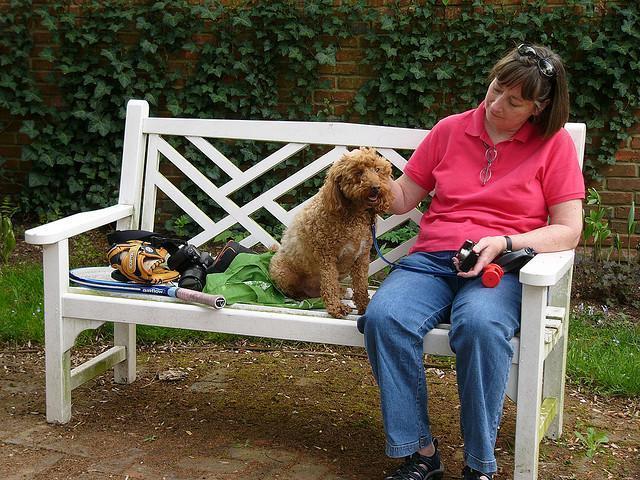How many glasses does the woman have?
Give a very brief answer. 1. How many pairs of jeans do you see?
Give a very brief answer. 1. How many benches are there?
Give a very brief answer. 2. How many horses are there?
Give a very brief answer. 0. 